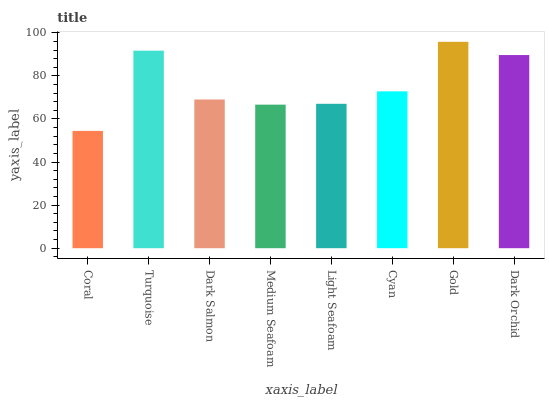Is Coral the minimum?
Answer yes or no. Yes. Is Gold the maximum?
Answer yes or no. Yes. Is Turquoise the minimum?
Answer yes or no. No. Is Turquoise the maximum?
Answer yes or no. No. Is Turquoise greater than Coral?
Answer yes or no. Yes. Is Coral less than Turquoise?
Answer yes or no. Yes. Is Coral greater than Turquoise?
Answer yes or no. No. Is Turquoise less than Coral?
Answer yes or no. No. Is Cyan the high median?
Answer yes or no. Yes. Is Dark Salmon the low median?
Answer yes or no. Yes. Is Dark Salmon the high median?
Answer yes or no. No. Is Gold the low median?
Answer yes or no. No. 